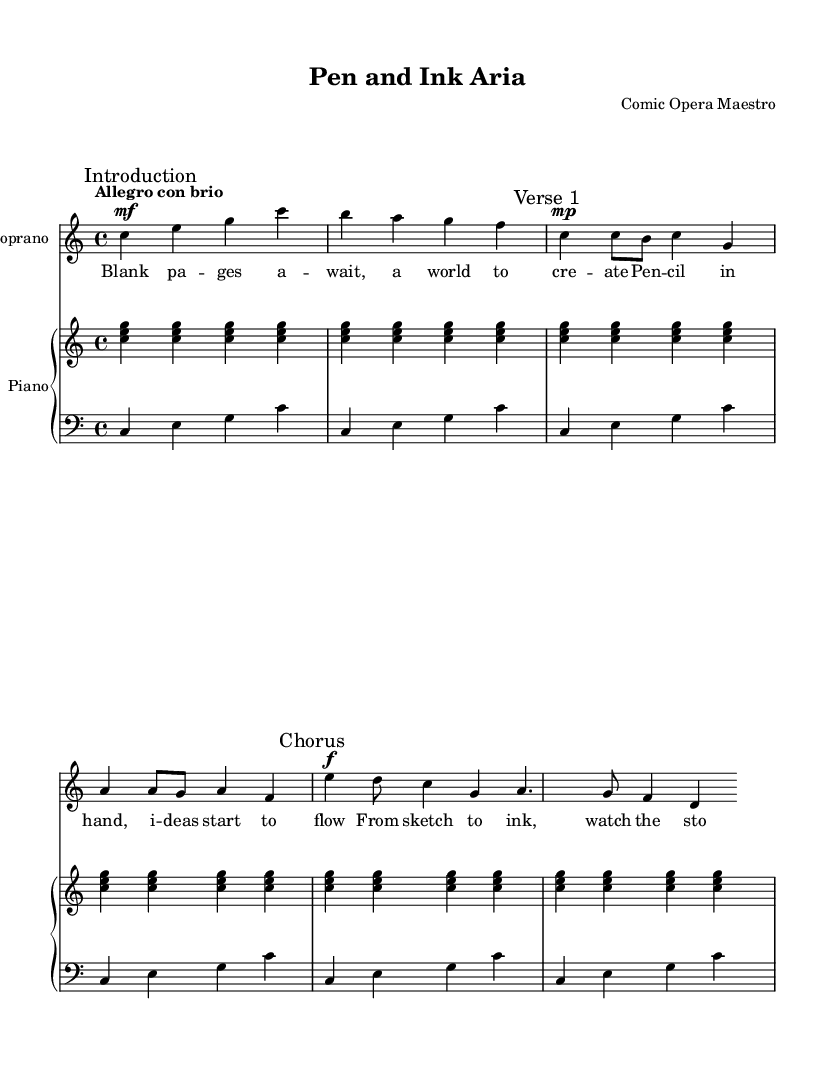What is the key signature of this music? The key signature is C major, which has no sharps or flats.
Answer: C major What is the time signature of this music? The time signature is identified as 4/4, indicating four beats per measure.
Answer: 4/4 What is the tempo marking for this piece? The tempo marking is "Allegro con brio," which indicates a fast and spirited tempo.
Answer: Allegro con brio How many verses are in the music? The music contains one verse, as indicated by the structure of the lyrics only showing one distinct section labeled as "Verse 1."
Answer: One What lyrical theme is presented in the chorus? The chorus describes the process of transforming sketches into a narrative through artistic creation, emphasizing storytelling.
Answer: Storytelling How does the aria reflect the creative process of comic book artists? The aria incorporates themes of creation and artistic flow, paralleling the journey from idea to visual story in comic book art.
Answer: Artistic creation What instruments are included in the score? The score includes a Soprano vocal part and a Piano accompaniment consisting of right and left hand parts.
Answer: Soprano and Piano 